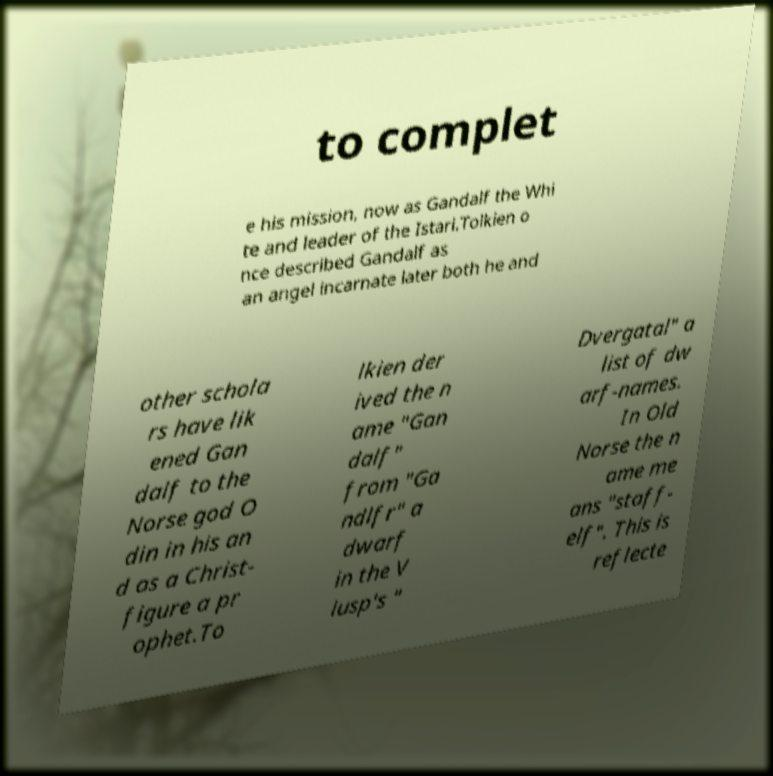Please read and relay the text visible in this image. What does it say? to complet e his mission, now as Gandalf the Whi te and leader of the Istari.Tolkien o nce described Gandalf as an angel incarnate later both he and other schola rs have lik ened Gan dalf to the Norse god O din in his an d as a Christ- figure a pr ophet.To lkien der ived the n ame "Gan dalf" from "Ga ndlfr" a dwarf in the V lusp's " Dvergatal" a list of dw arf-names. In Old Norse the n ame me ans "staff- elf". This is reflecte 